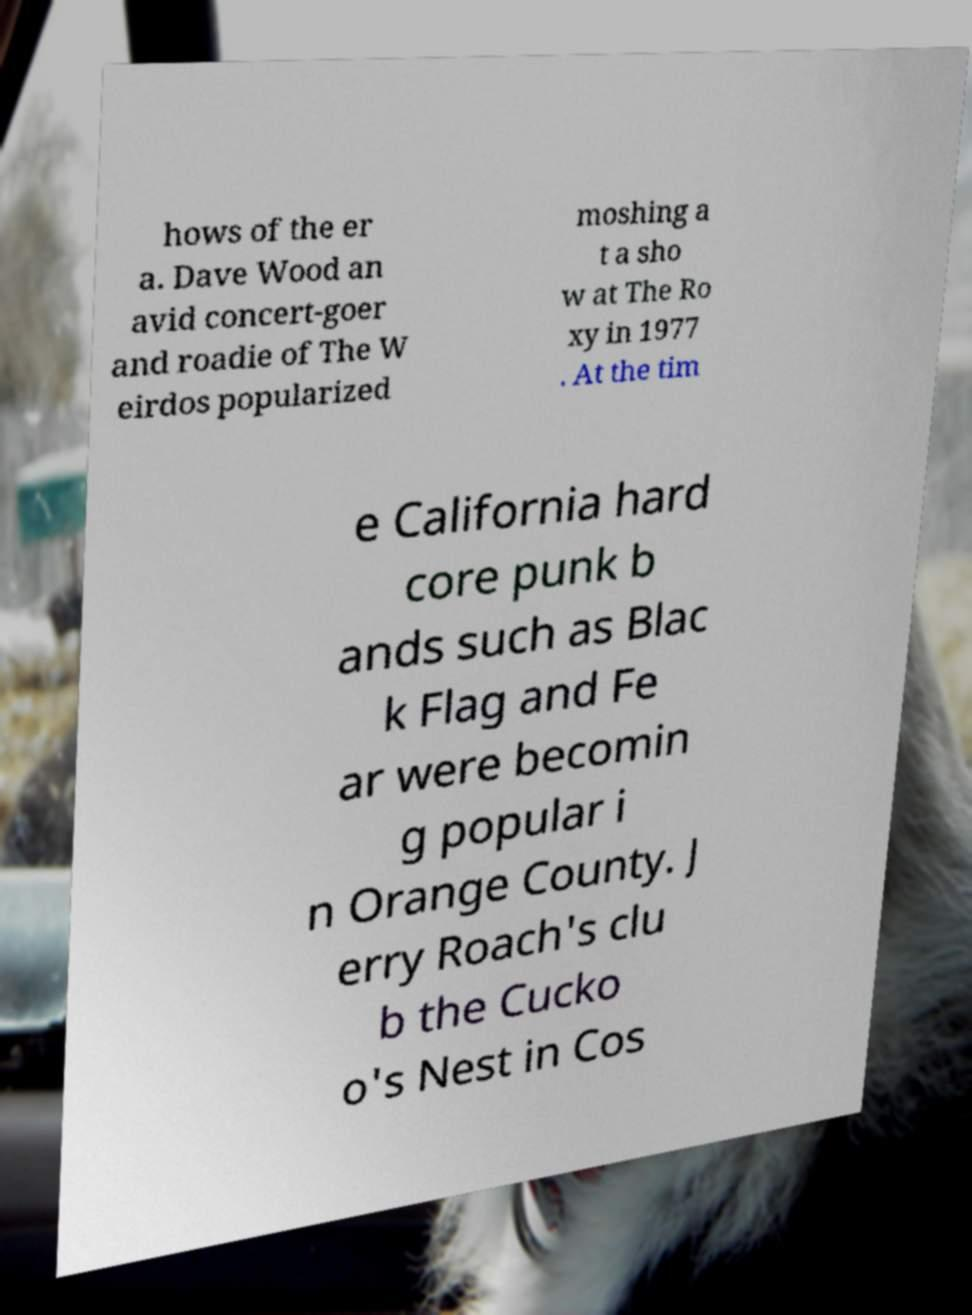Please identify and transcribe the text found in this image. hows of the er a. Dave Wood an avid concert-goer and roadie of The W eirdos popularized moshing a t a sho w at The Ro xy in 1977 . At the tim e California hard core punk b ands such as Blac k Flag and Fe ar were becomin g popular i n Orange County. J erry Roach's clu b the Cucko o's Nest in Cos 